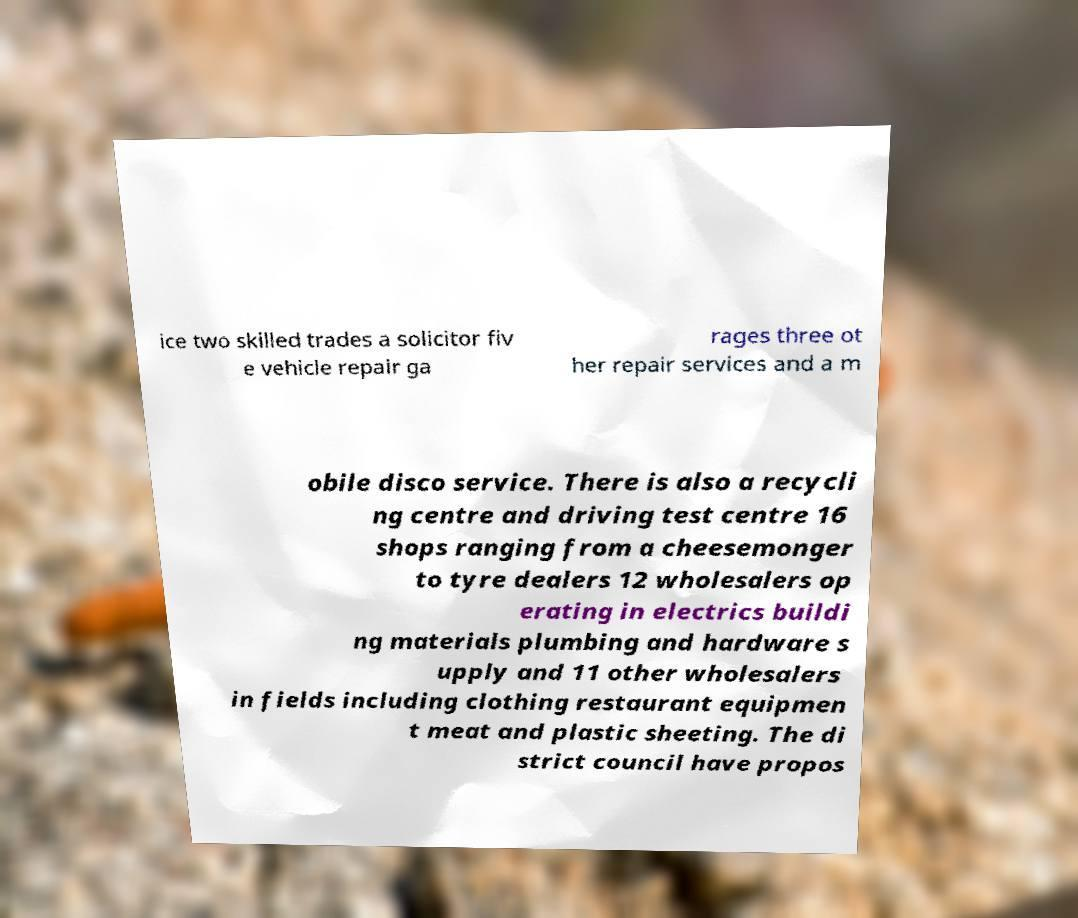Please read and relay the text visible in this image. What does it say? ice two skilled trades a solicitor fiv e vehicle repair ga rages three ot her repair services and a m obile disco service. There is also a recycli ng centre and driving test centre 16 shops ranging from a cheesemonger to tyre dealers 12 wholesalers op erating in electrics buildi ng materials plumbing and hardware s upply and 11 other wholesalers in fields including clothing restaurant equipmen t meat and plastic sheeting. The di strict council have propos 